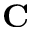Convert formula to latex. <formula><loc_0><loc_0><loc_500><loc_500>C</formula> 